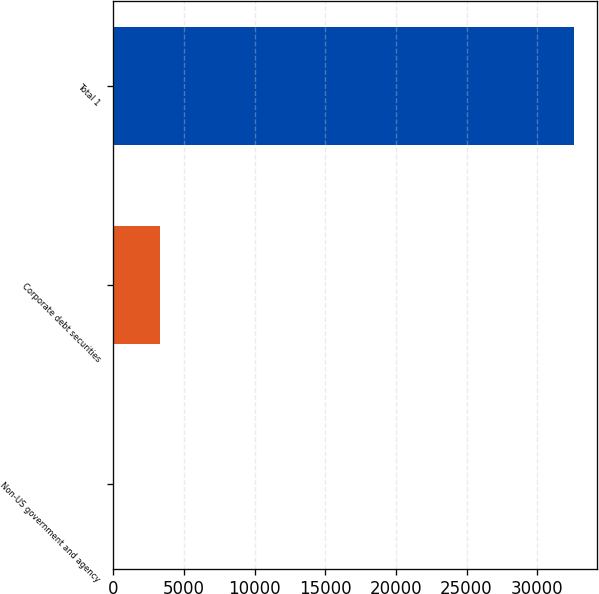Convert chart to OTSL. <chart><loc_0><loc_0><loc_500><loc_500><bar_chart><fcel>Non-US government and agency<fcel>Corporate debt securities<fcel>Total 1<nl><fcel>40<fcel>3299.9<fcel>32639<nl></chart> 